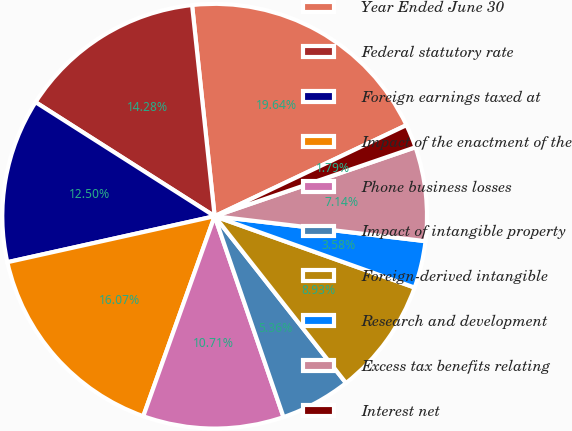<chart> <loc_0><loc_0><loc_500><loc_500><pie_chart><fcel>Year Ended June 30<fcel>Federal statutory rate<fcel>Foreign earnings taxed at<fcel>Impact of the enactment of the<fcel>Phone business losses<fcel>Impact of intangible property<fcel>Foreign-derived intangible<fcel>Research and development<fcel>Excess tax benefits relating<fcel>Interest net<nl><fcel>19.64%<fcel>14.28%<fcel>12.5%<fcel>16.07%<fcel>10.71%<fcel>5.36%<fcel>8.93%<fcel>3.58%<fcel>7.14%<fcel>1.79%<nl></chart> 